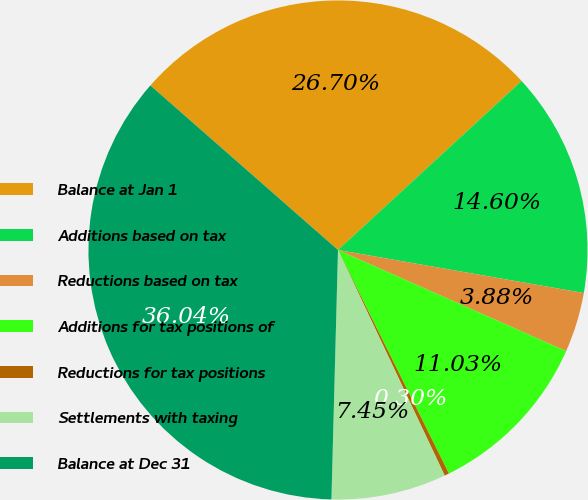<chart> <loc_0><loc_0><loc_500><loc_500><pie_chart><fcel>Balance at Jan 1<fcel>Additions based on tax<fcel>Reductions based on tax<fcel>Additions for tax positions of<fcel>Reductions for tax positions<fcel>Settlements with taxing<fcel>Balance at Dec 31<nl><fcel>26.7%<fcel>14.6%<fcel>3.88%<fcel>11.03%<fcel>0.3%<fcel>7.45%<fcel>36.04%<nl></chart> 